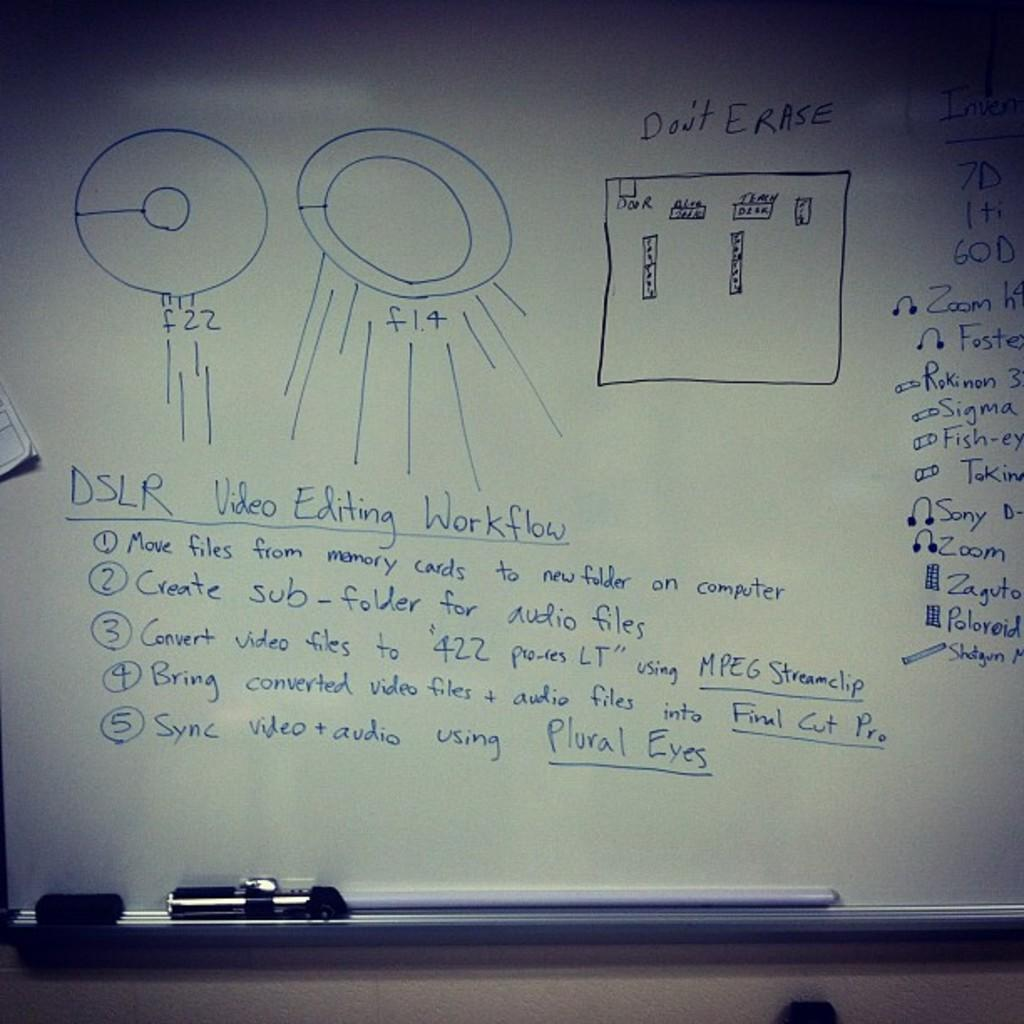<image>
Write a terse but informative summary of the picture. A whiteboard with important information and Don't Erase on it. 